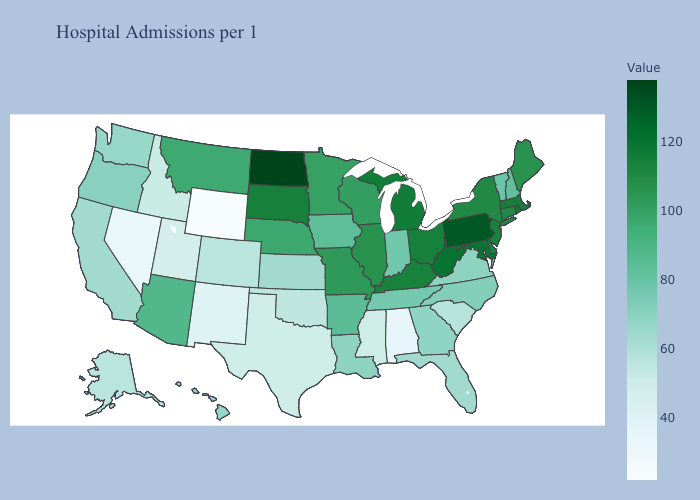Is the legend a continuous bar?
Write a very short answer. Yes. Among the states that border Iowa , does Missouri have the highest value?
Be succinct. No. Among the states that border New York , does Connecticut have the highest value?
Short answer required. No. Among the states that border Indiana , which have the lowest value?
Quick response, please. Illinois. Among the states that border Iowa , which have the highest value?
Concise answer only. South Dakota. Does Idaho have a lower value than Arizona?
Keep it brief. Yes. 